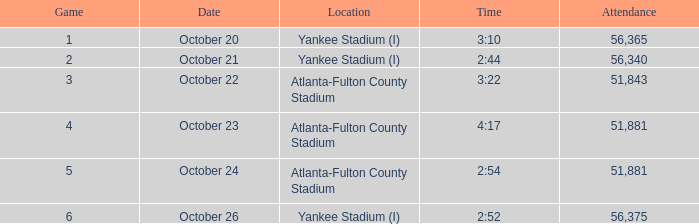What is the greatest game number with a duration of 2 minutes and 44 seconds? 2.0. 